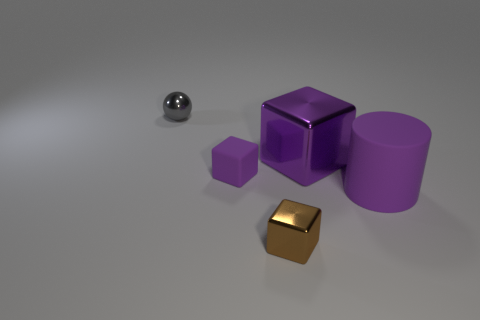Subtract all large cubes. How many cubes are left? 2 Subtract all purple blocks. How many blocks are left? 1 Subtract all blocks. How many objects are left? 2 Add 3 tiny green metallic spheres. How many objects exist? 8 Subtract all purple blocks. How many cyan cylinders are left? 0 Subtract all purple balls. Subtract all large purple cylinders. How many objects are left? 4 Add 2 large rubber cylinders. How many large rubber cylinders are left? 3 Add 2 big cubes. How many big cubes exist? 3 Subtract 0 red blocks. How many objects are left? 5 Subtract 1 cubes. How many cubes are left? 2 